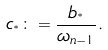<formula> <loc_0><loc_0><loc_500><loc_500>c _ { ^ { * } } \colon = \frac { b _ { ^ { * } } } { \omega _ { n - 1 } } .</formula> 